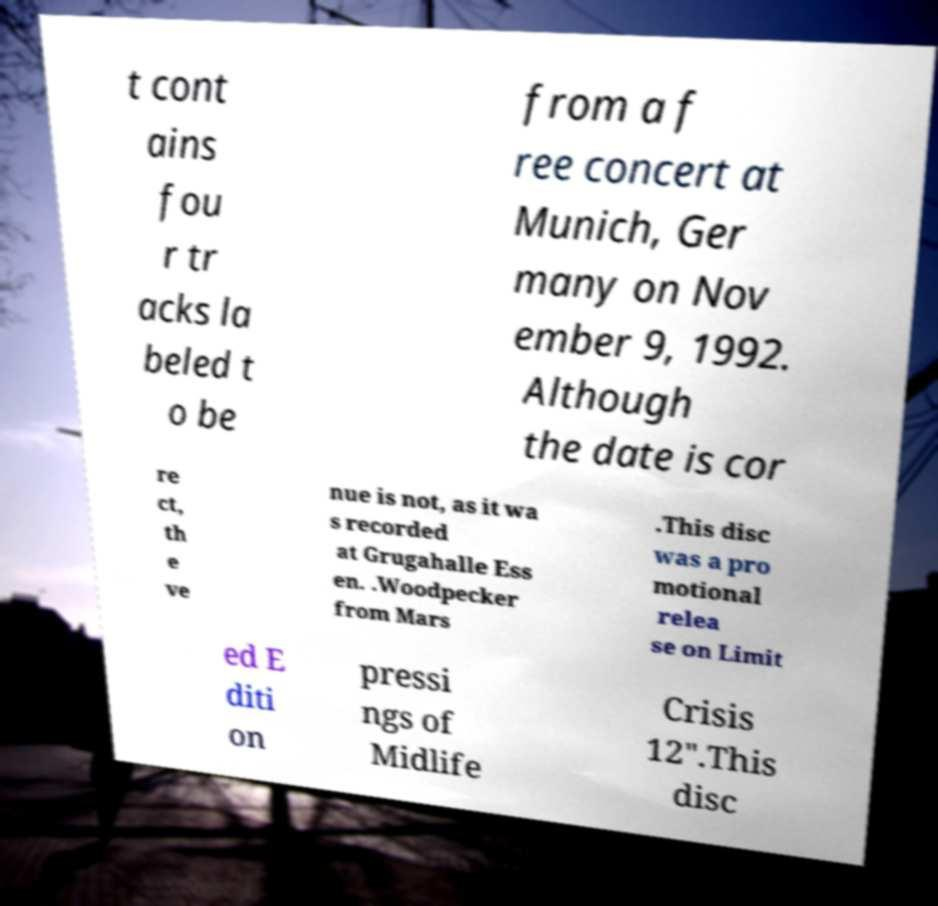I need the written content from this picture converted into text. Can you do that? t cont ains fou r tr acks la beled t o be from a f ree concert at Munich, Ger many on Nov ember 9, 1992. Although the date is cor re ct, th e ve nue is not, as it wa s recorded at Grugahalle Ess en. .Woodpecker from Mars .This disc was a pro motional relea se on Limit ed E diti on pressi ngs of Midlife Crisis 12".This disc 